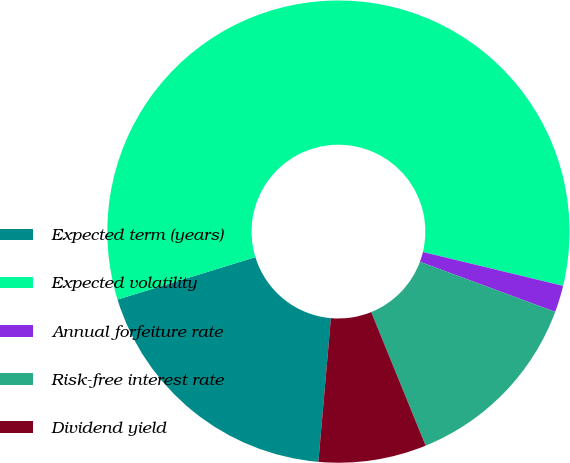Convert chart to OTSL. <chart><loc_0><loc_0><loc_500><loc_500><pie_chart><fcel>Expected term (years)<fcel>Expected volatility<fcel>Annual forfeiture rate<fcel>Risk-free interest rate<fcel>Dividend yield<nl><fcel>18.87%<fcel>58.52%<fcel>1.87%<fcel>13.2%<fcel>7.54%<nl></chart> 